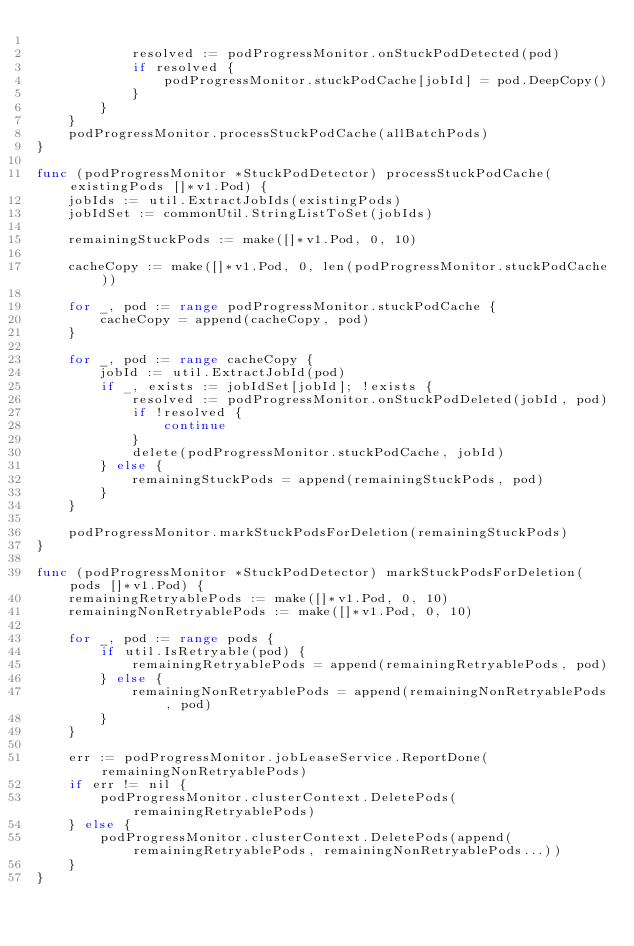Convert code to text. <code><loc_0><loc_0><loc_500><loc_500><_Go_>
			resolved := podProgressMonitor.onStuckPodDetected(pod)
			if resolved {
				podProgressMonitor.stuckPodCache[jobId] = pod.DeepCopy()
			}
		}
	}
	podProgressMonitor.processStuckPodCache(allBatchPods)
}

func (podProgressMonitor *StuckPodDetector) processStuckPodCache(existingPods []*v1.Pod) {
	jobIds := util.ExtractJobIds(existingPods)
	jobIdSet := commonUtil.StringListToSet(jobIds)

	remainingStuckPods := make([]*v1.Pod, 0, 10)

	cacheCopy := make([]*v1.Pod, 0, len(podProgressMonitor.stuckPodCache))

	for _, pod := range podProgressMonitor.stuckPodCache {
		cacheCopy = append(cacheCopy, pod)
	}

	for _, pod := range cacheCopy {
		jobId := util.ExtractJobId(pod)
		if _, exists := jobIdSet[jobId]; !exists {
			resolved := podProgressMonitor.onStuckPodDeleted(jobId, pod)
			if !resolved {
				continue
			}
			delete(podProgressMonitor.stuckPodCache, jobId)
		} else {
			remainingStuckPods = append(remainingStuckPods, pod)
		}
	}

	podProgressMonitor.markStuckPodsForDeletion(remainingStuckPods)
}

func (podProgressMonitor *StuckPodDetector) markStuckPodsForDeletion(pods []*v1.Pod) {
	remainingRetryablePods := make([]*v1.Pod, 0, 10)
	remainingNonRetryablePods := make([]*v1.Pod, 0, 10)

	for _, pod := range pods {
		if util.IsRetryable(pod) {
			remainingRetryablePods = append(remainingRetryablePods, pod)
		} else {
			remainingNonRetryablePods = append(remainingNonRetryablePods, pod)
		}
	}

	err := podProgressMonitor.jobLeaseService.ReportDone(remainingNonRetryablePods)
	if err != nil {
		podProgressMonitor.clusterContext.DeletePods(remainingRetryablePods)
	} else {
		podProgressMonitor.clusterContext.DeletePods(append(remainingRetryablePods, remainingNonRetryablePods...))
	}
}
</code> 